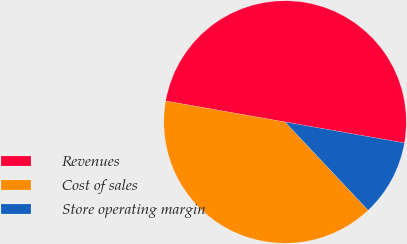Convert chart to OTSL. <chart><loc_0><loc_0><loc_500><loc_500><pie_chart><fcel>Revenues<fcel>Cost of sales<fcel>Store operating margin<nl><fcel>50.0%<fcel>39.79%<fcel>10.21%<nl></chart> 